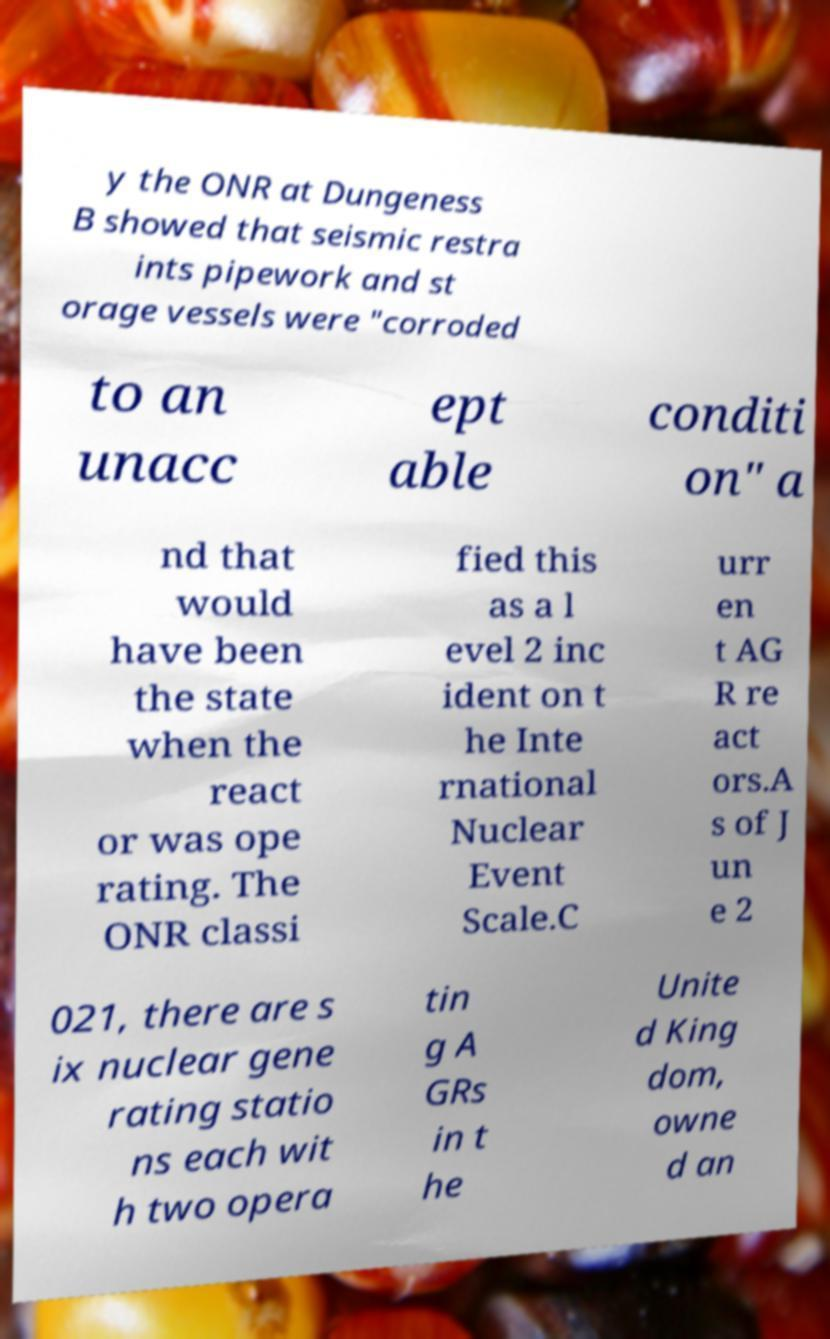For documentation purposes, I need the text within this image transcribed. Could you provide that? y the ONR at Dungeness B showed that seismic restra ints pipework and st orage vessels were "corroded to an unacc ept able conditi on" a nd that would have been the state when the react or was ope rating. The ONR classi fied this as a l evel 2 inc ident on t he Inte rnational Nuclear Event Scale.C urr en t AG R re act ors.A s of J un e 2 021, there are s ix nuclear gene rating statio ns each wit h two opera tin g A GRs in t he Unite d King dom, owne d an 